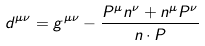<formula> <loc_0><loc_0><loc_500><loc_500>d ^ { \mu \nu } = g ^ { \mu \nu } - \frac { P ^ { \mu } n ^ { \nu } + n ^ { \mu } P ^ { \nu } } { n \cdot P }</formula> 